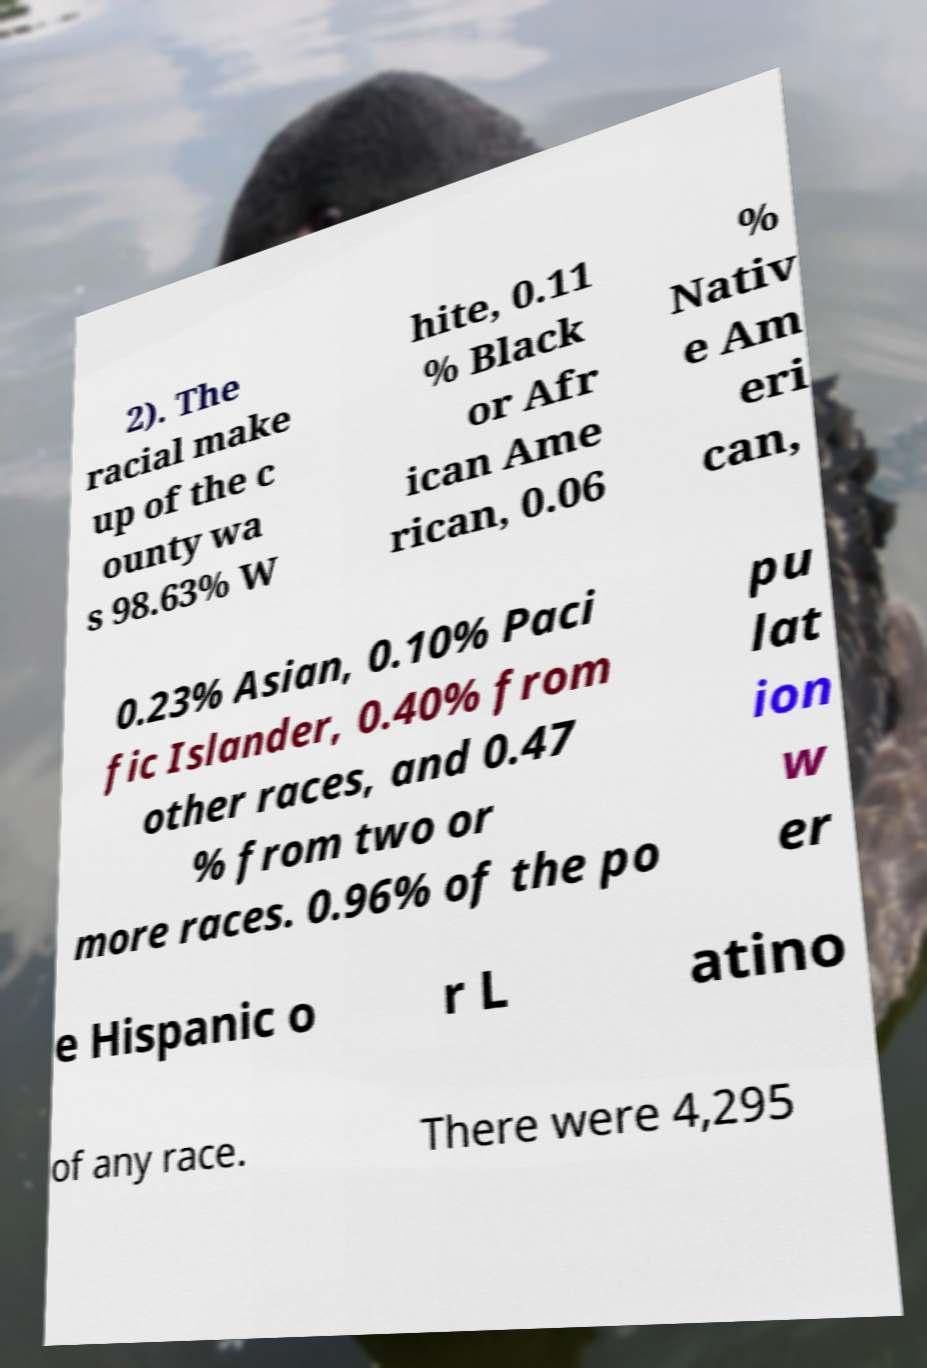For documentation purposes, I need the text within this image transcribed. Could you provide that? 2). The racial make up of the c ounty wa s 98.63% W hite, 0.11 % Black or Afr ican Ame rican, 0.06 % Nativ e Am eri can, 0.23% Asian, 0.10% Paci fic Islander, 0.40% from other races, and 0.47 % from two or more races. 0.96% of the po pu lat ion w er e Hispanic o r L atino of any race. There were 4,295 